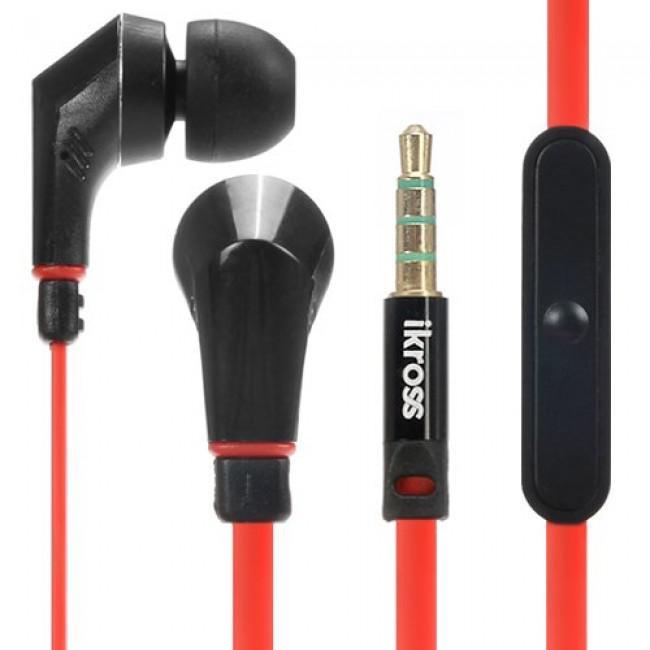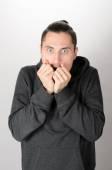The first image is the image on the left, the second image is the image on the right. Evaluate the accuracy of this statement regarding the images: "The left and right image contains the same number of men.". Is it true? Answer yes or no. No. 